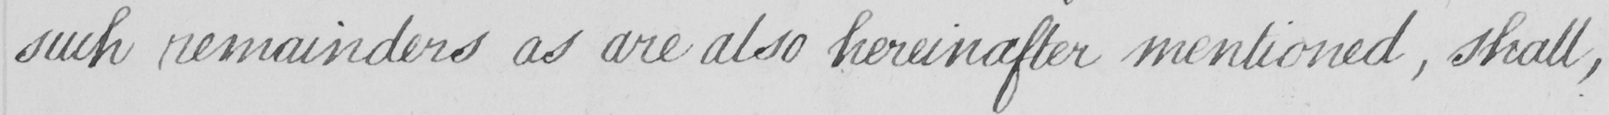What is written in this line of handwriting? such remainders as are also hereinafter mentioned , shall , 